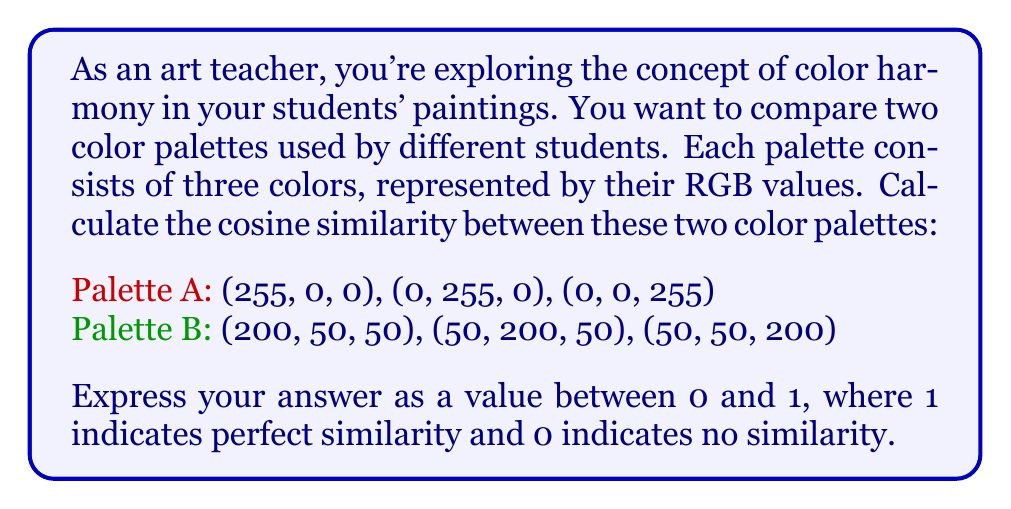Could you help me with this problem? To calculate the similarity between two color palettes using vector operations, we can treat each palette as a vector and use the cosine similarity formula. Here's how to approach this problem:

1. Represent each palette as a single vector:
   Palette A: $A = [255, 0, 0, 0, 255, 0, 0, 0, 255]$
   Palette B: $B = [200, 50, 50, 50, 200, 50, 50, 50, 200]$

2. Calculate the dot product of A and B:
   $$A \cdot B = (255 \times 200) + (0 \times 50) + (0 \times 50) + (0 \times 50) + (255 \times 200) + (0 \times 50) + (0 \times 50) + (0 \times 50) + (255 \times 200)$$
   $$A \cdot B = 51000 + 51000 + 51000 = 153000$$

3. Calculate the magnitude (length) of each vector:
   $$\|A\| = \sqrt{255^2 + 0^2 + 0^2 + 0^2 + 255^2 + 0^2 + 0^2 + 0^2 + 255^2} = \sqrt{195075} \approx 441.67$$
   $$\|B\| = \sqrt{200^2 + 50^2 + 50^2 + 50^2 + 200^2 + 50^2 + 50^2 + 50^2 + 200^2} = \sqrt{127500} \approx 356.93$$

4. Apply the cosine similarity formula:
   $$\text{cosine similarity} = \frac{A \cdot B}{\|A\| \times \|B\|}$$
   $$\text{cosine similarity} = \frac{153000}{441.67 \times 356.93} \approx 0.9701$$

The cosine similarity ranges from -1 to 1, but since we're dealing with non-negative RGB values, our result will be between 0 and 1.
Answer: The cosine similarity between the two color palettes is approximately 0.9701. 